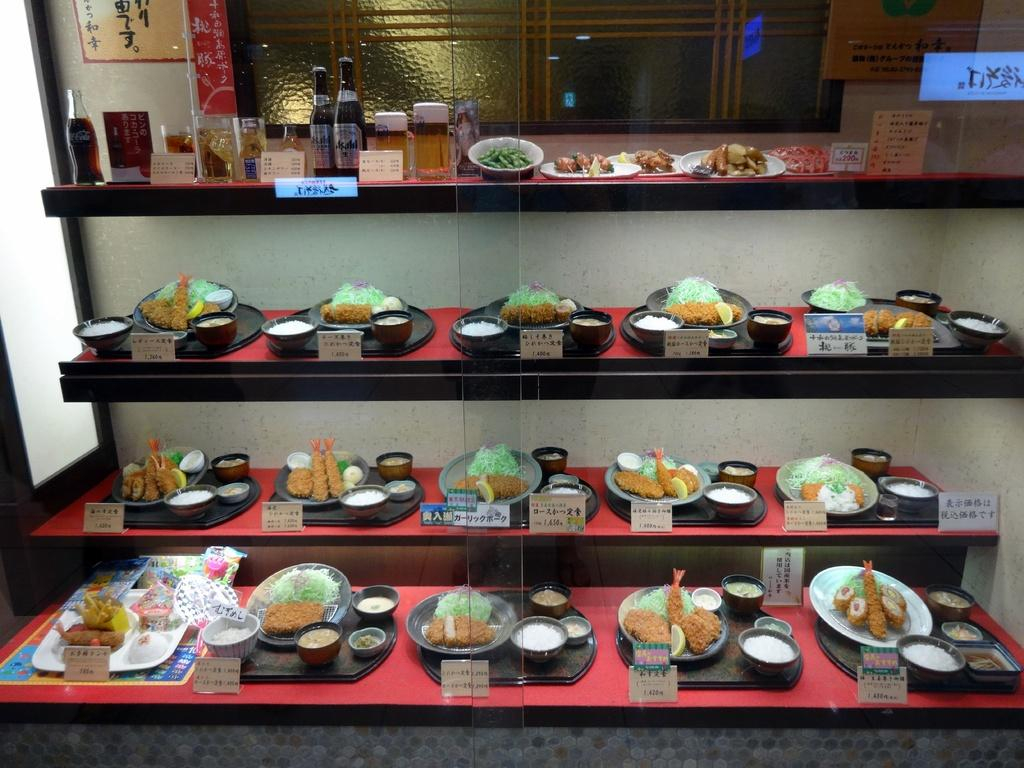What types of items can be seen in the image? There are food items and drinks in the image. Where are the food items and drinks located? The food items and drinks are on shelves in the image. How can one identify the specific dishes in the image? The name of each dish is beside the corresponding food item in the image. What is visible in the background of the image? There is a wall in the background of the image. Can you see a dog eating cherries while wearing a collar in the image? No, there is no dog, cherries, or collar present in the image. 